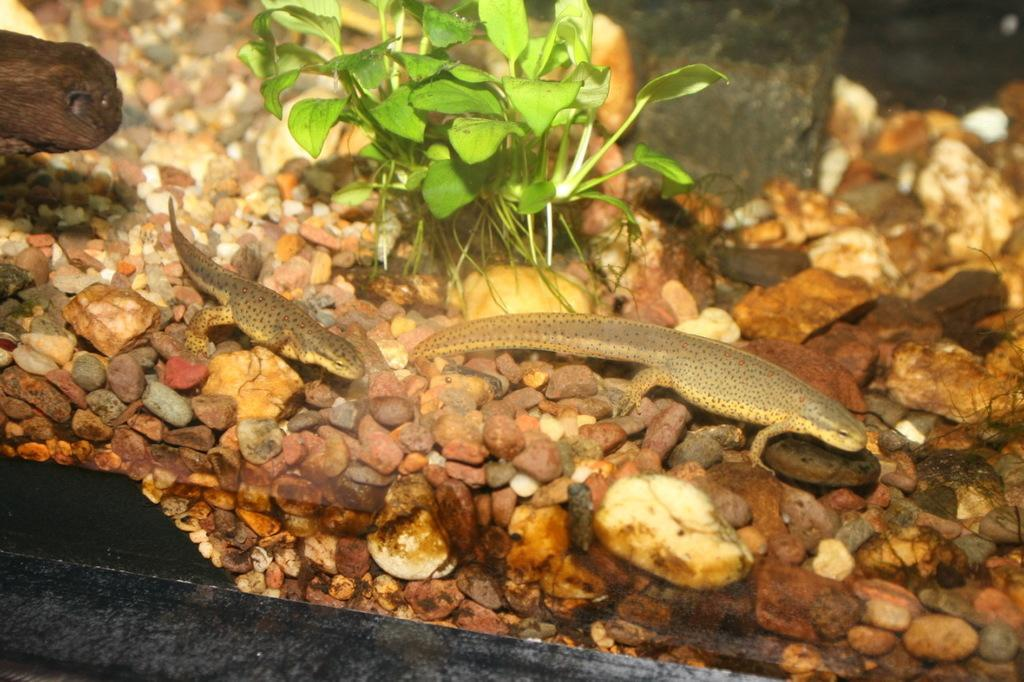What is the main feature of the image? There is an aquarium in the image. What type of animals can be seen in the aquarium? There are reptiles in the water of the aquarium. What else can be seen in the aquarium besides the reptiles? There are water plants visible in the aquarium. What is at the bottom of the aquarium? There are stones at the bottom of the aquarium. What type of art can be seen hanging on the wall behind the aquarium? There is no art visible in the image; it only shows the aquarium and its contents. 